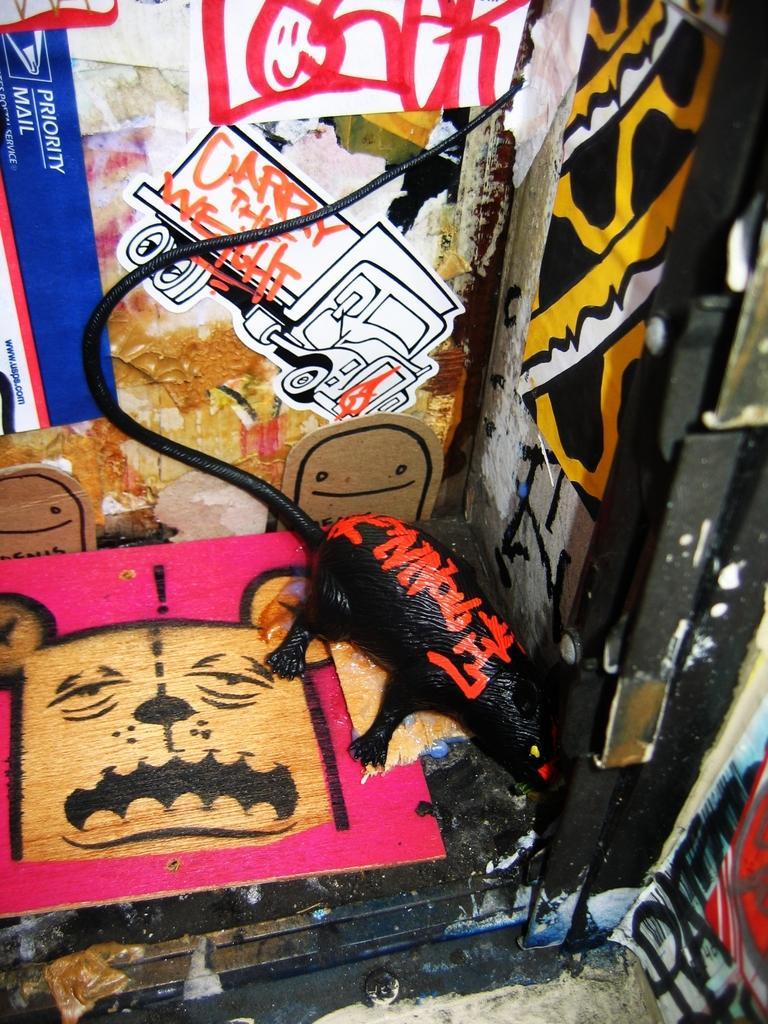Could you give a brief overview of what you see in this image? In this picture, we see some posts are posted on the wall. At the bottom of the picture, we see a black color table on which a pink color board with painting is placed. Beside that, we see a toy rat. We even see graffiti. 